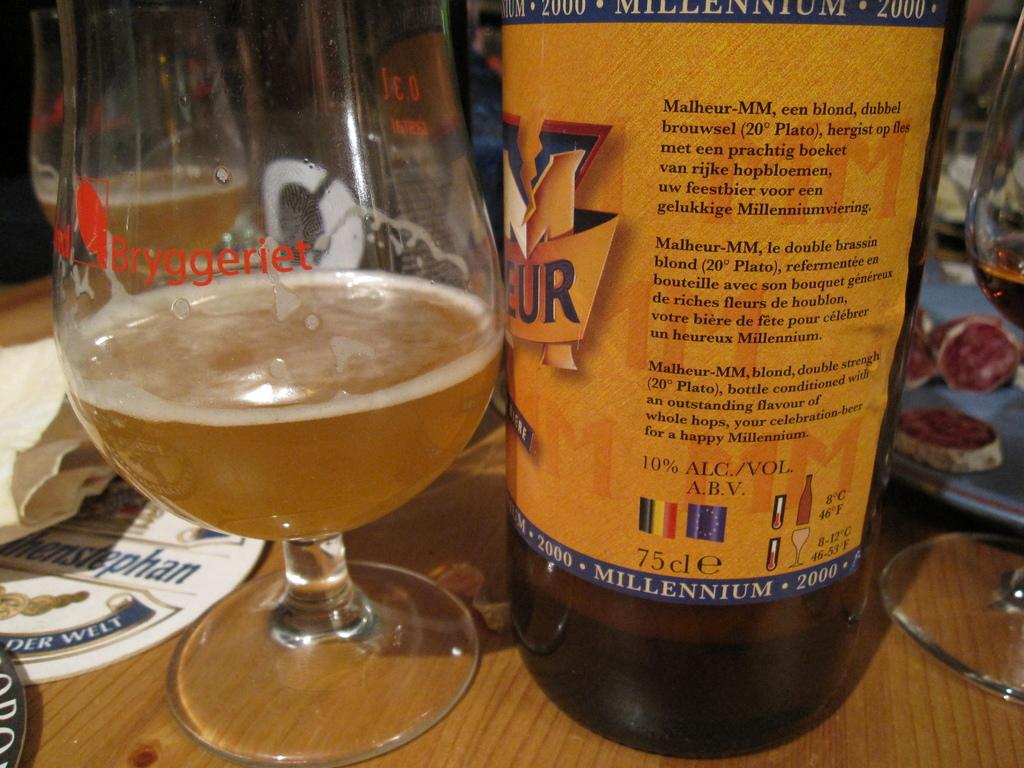What is present on the table in the image? There is a bottle and a glass on the table in the image. Can you describe the objects on the table? The objects on the table are a bottle and a glass. What time of day is it in the image, as indicated by the morning light? There is no indication of the time of day or any light source in the image. How does the glass push the bottle off the table? The glass does not push the bottle off the table in the image; both objects are stationary on the table. 